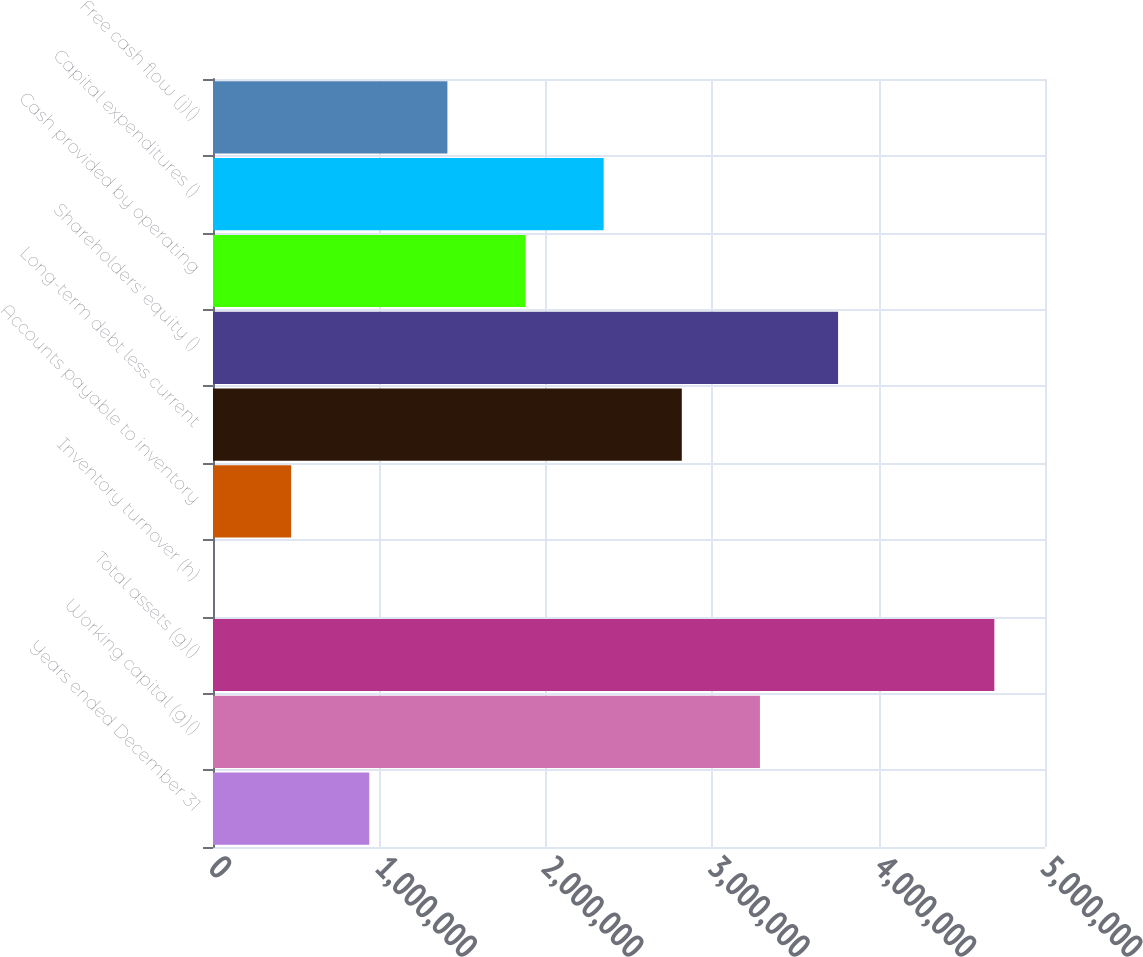<chart> <loc_0><loc_0><loc_500><loc_500><bar_chart><fcel>Years ended December 31<fcel>Working capital (g)()<fcel>Total assets (g)()<fcel>Inventory turnover (h)<fcel>Accounts payable to inventory<fcel>Long-term debt less current<fcel>Shareholders' equity ()<fcel>Cash provided by operating<fcel>Capital expenditures ()<fcel>Free cash flow (j)()<nl><fcel>939108<fcel>3.28688e+06<fcel>4.69554e+06<fcel>1.4<fcel>469555<fcel>2.81732e+06<fcel>3.75643e+06<fcel>1.87822e+06<fcel>2.34777e+06<fcel>1.40866e+06<nl></chart> 